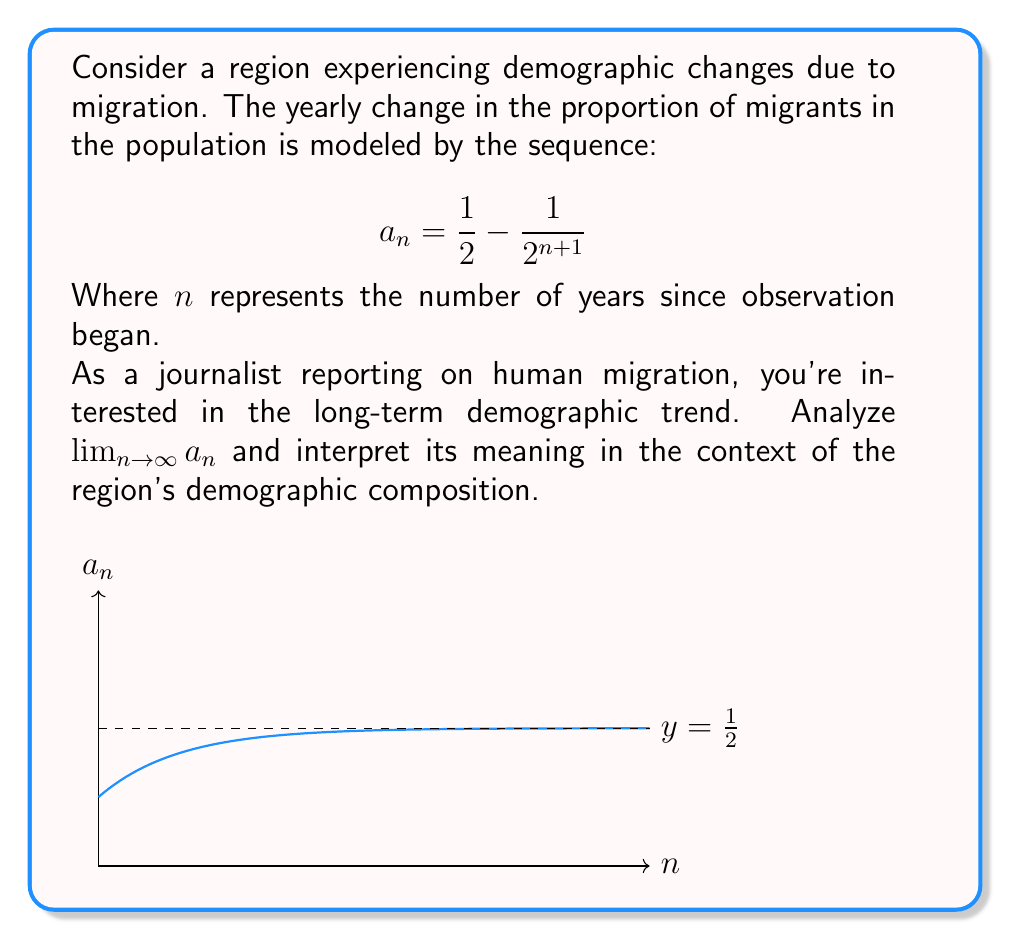Provide a solution to this math problem. Let's approach this step-by-step:

1) First, we need to evaluate $\lim_{n \to \infty} a_n$. This means we need to find what happens to $a_n$ as $n$ gets very large.

2) Let's look at the sequence again:

   $$a_n = \frac{1}{2} - \frac{1}{2^{n+1}}$$

3) As $n$ approaches infinity, $2^{n+1}$ becomes extremely large. Therefore, $\frac{1}{2^{n+1}}$ approaches 0.

4) We can verify this mathematically:

   $$\lim_{n \to \infty} \frac{1}{2^{n+1}} = 0$$

5) Now, let's apply this to our original sequence:

   $$\lim_{n \to \infty} a_n = \lim_{n \to \infty} (\frac{1}{2} - \frac{1}{2^{n+1}})$$

6) Using the limit laws, we can separate this:

   $$= \lim_{n \to \infty} \frac{1}{2} - \lim_{n \to \infty} \frac{1}{2^{n+1}}$$

7) We know the limit of a constant is the constant itself, and we've already established that the second term approaches 0:

   $$= \frac{1}{2} - 0 = \frac{1}{2}$$

8) Interpretation: This limit means that as time progresses (as $n$ increases), the proportion of migrants in the population approaches 50%. In other words, in the long run, the region's population is expected to be composed of half migrants and half non-migrants.
Answer: $\lim_{n \to \infty} a_n = \frac{1}{2}$ 